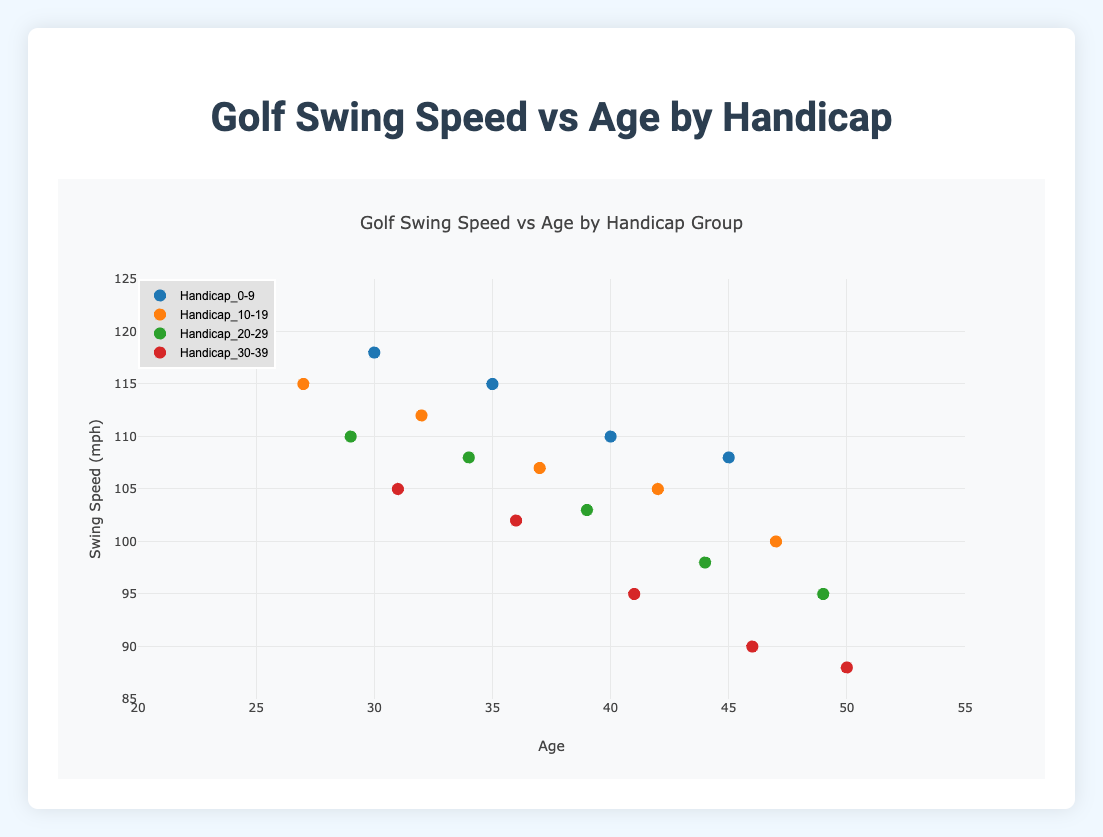How many data points are in the Handicap_10-19 group? Count the number of data points within the Handicap_10-19 series. The data indicates there are 5 individuals in this group.
Answer: 5 What is the age range represented in the Handicap_0-9 group? The youngest and oldest ages in the Handicap_0-9 group are 25 and 45, respectively. This means the age range for this group is from 25 to 45.
Answer: 25 to 45 Which handicap group shows the highest swing speed for its oldest player? In the figure, we need to identify the swing speed of the oldest players across all handicap groups. For the Handicap_0-9 group, the oldest player at age 45 has a swing speed of 108 mph. For Handicap_10-19, the oldest player at age 47 has 100 mph. For Handicap_20-29, at age 49 is 95 mph. Finally, for Handicap_30-39, at age 50 is 88 mph. Therefore, Handicap_0-9 has the highest swing speed for its oldest player.
Answer: Handicap_0-9 Is the correlation between age and swing speed positive or negative? Observing the scatter plots for each handicap group, it appears that as age increases, swing speed generally decreases across all groups. This indicates a negative correlation between age and swing speed.
Answer: Negative Which handicap group has the most consistent swing speed values? Checking the spread of the data points for each group, we see that Handicap_0-9 has points that are relatively close together compared to other groups, indicating consistency in swing speeds.
Answer: Handicap_0-9 What is the swing speed of the youngest player in the Handicap_30-39 group? The youngest player in the Handicap_30-39 group is 31 years old, with a swing speed of 105 mph.
Answer: 105 mph What is the difference in swing speed between the youngest and oldest players in the Handicap_20-29 group? The youngest player in the Handicap_20-29 group is 29 years old with a swing speed of 110 mph. The oldest is 49 years old with 95 mph. The difference is 110 - 95.
Answer: 15 mph What group has the lowest average swing speed? Calculate the average swing speed for each group. In Handicap_0-9: (120 + 118 + 115 + 110 + 108)/5 = 114.2. Handicap_10-19: (115 + 112 + 107 + 105 + 100)/5 = 107.8. Handicap_20-29: (110 + 108 + 103 + 98 + 95)/5 = 102.8. Handicap_30-39: (105 + 102 + 95 + 90 + 88)/5 = 96.
Answer: Handicap_30-39 